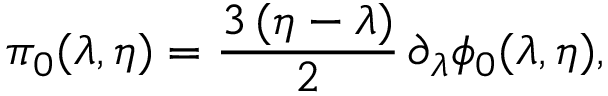<formula> <loc_0><loc_0><loc_500><loc_500>\pi _ { 0 } ( \lambda , \eta ) = { \frac { 3 \, ( \eta - \lambda ) } { 2 } } \, \partial _ { \lambda } \phi _ { 0 } ( \lambda , \eta ) ,</formula> 